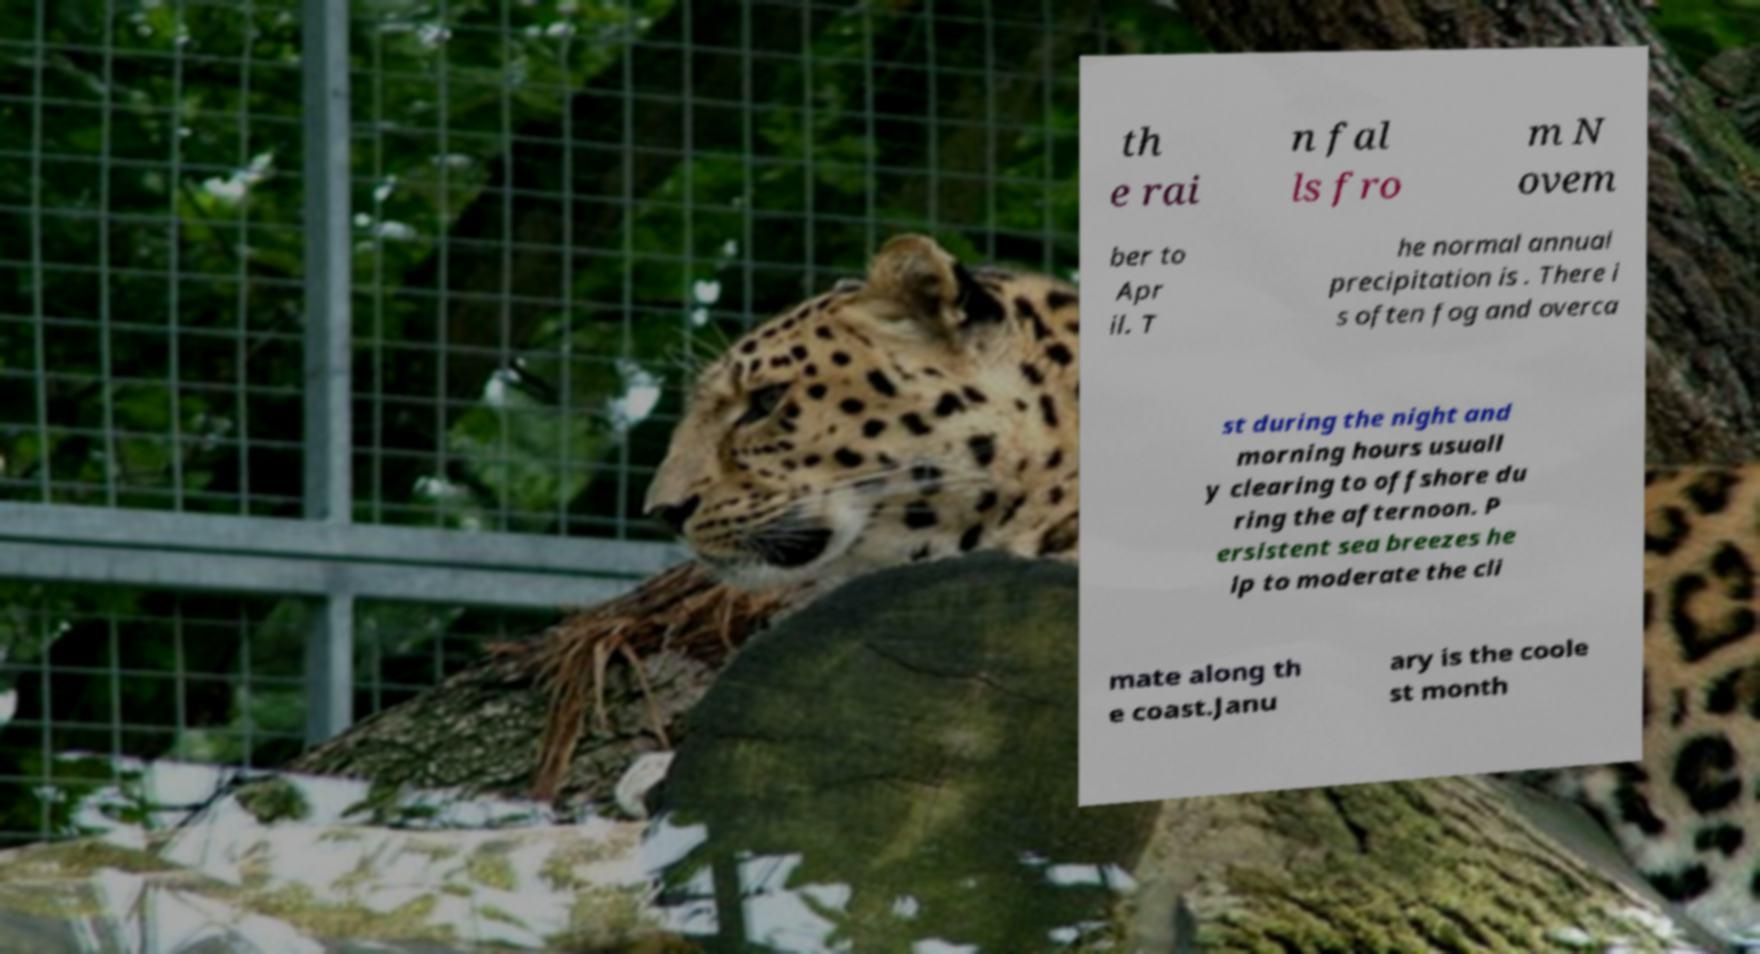For documentation purposes, I need the text within this image transcribed. Could you provide that? th e rai n fal ls fro m N ovem ber to Apr il. T he normal annual precipitation is . There i s often fog and overca st during the night and morning hours usuall y clearing to offshore du ring the afternoon. P ersistent sea breezes he lp to moderate the cli mate along th e coast.Janu ary is the coole st month 